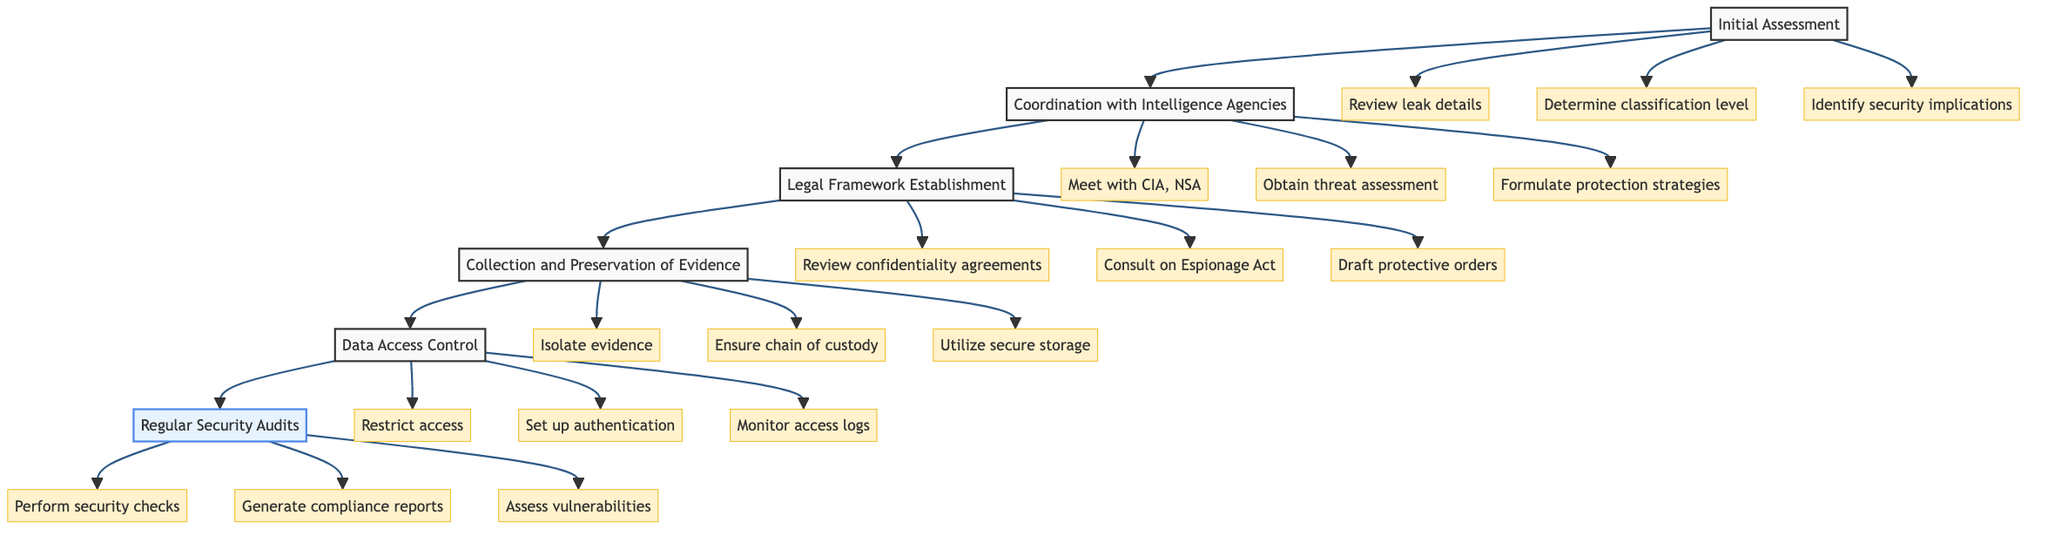What is the first step in the flow chart? The first step in the diagram is labeled "Initial Assessment", indicating it is the starting point of the process.
Answer: Initial Assessment Who is responsible for the "Collection and Preservation of Evidence"? The responsibility for this step is assigned to the "Evidence Custodian, Forensics Team", as indicated in the diagram.
Answer: Evidence Custodian, Forensics Team How many key actions are associated with "Legal Framework Establishment"? The diagram shows that "Legal Framework Establishment" involves three key actions, as represented by the three actions stemming from that node.
Answer: 3 What follows "Data Access Control" in the sequence of steps? The next step that comes after "Data Access Control" in the flow chart is "Regular Security Audits", directly connected by an arrow in the diagram.
Answer: Regular Security Audits What key action is taken during the "Initial Assessment"? The key actions listed under "Initial Assessment" include "Review received leak details", which is the first action connected to that step.
Answer: Review received leak details Which steps involve the "Lead Prosecutor" as a responsible party? The "Lead Prosecutor" is involved in the steps: "Initial Assessment", "Coordination with Intelligence Agencies", "Legal Framework Establishment", and "Data Access Control", as shown in the diagram.
Answer: 4 steps Which step is most concerned with evidence handling? "Collection and Preservation of Evidence" is the step that focuses primarily on securely managing evidence related to the leak, as indicated in its title and description.
Answer: Collection and Preservation of Evidence What is the focus of the "Regular Security Audits"? The focus of "Regular Security Audits" is to ensure compliance with security protocols, as stated in its description within the diagram.
Answer: Ensure compliance with security protocols Which action is aimed at restricting access to classified data? The action labeled "Restrict access to investigation team only" directly addresses the restriction of access to sensitive information, as indicated under "Data Access Control".
Answer: Restrict access to investigation team only 